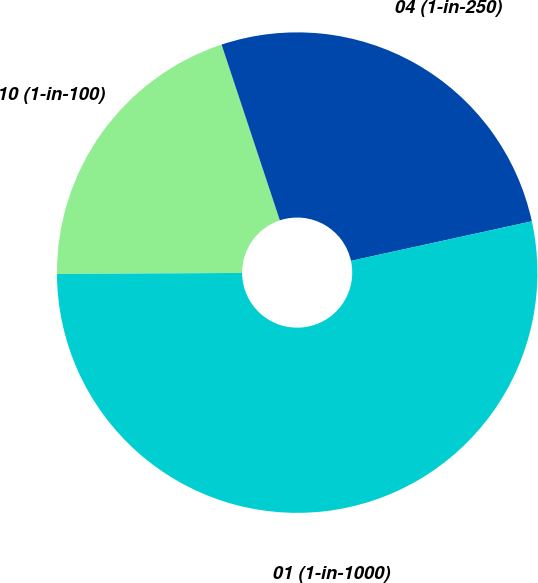Convert chart to OTSL. <chart><loc_0><loc_0><loc_500><loc_500><pie_chart><fcel>10 (1-in-100)<fcel>04 (1-in-250)<fcel>01 (1-in-1000)<nl><fcel>20.0%<fcel>26.67%<fcel>53.33%<nl></chart> 